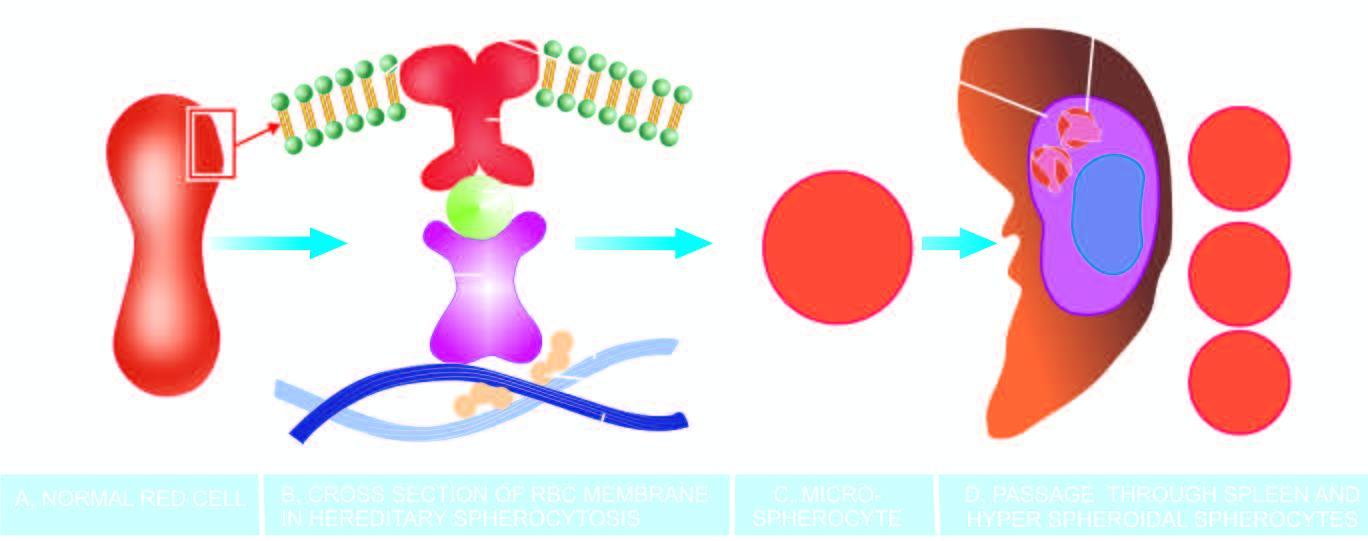what does this produce?
Answer the question using a single word or phrase. A circulating subpopulation of hyperspheroidal spherocytes 